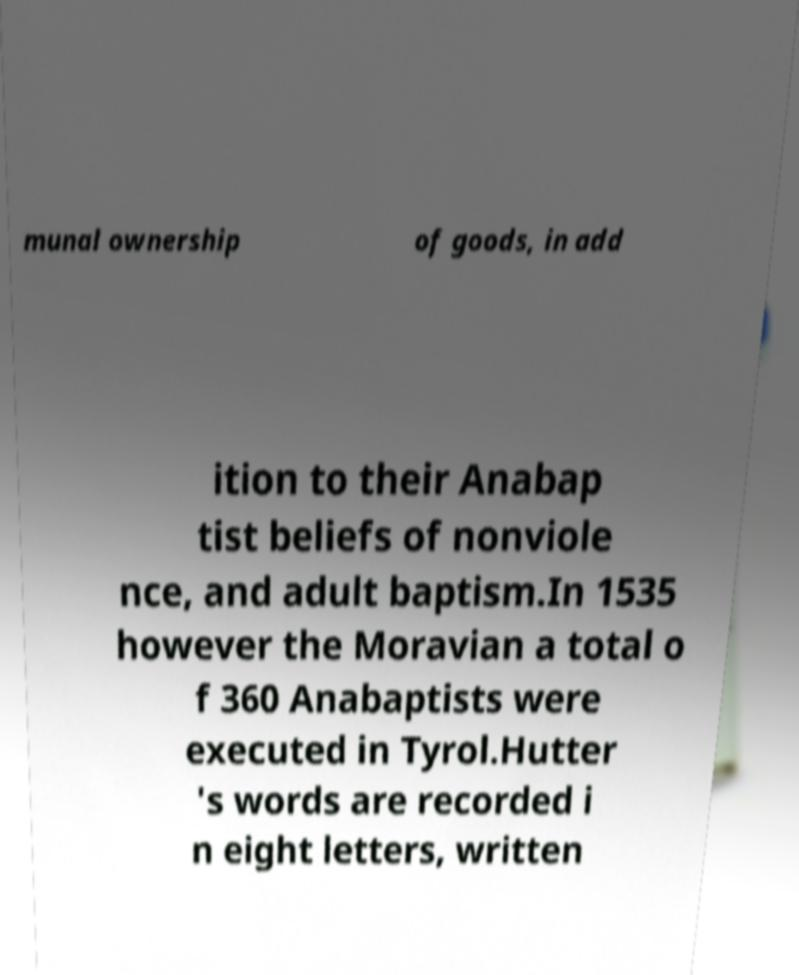Please identify and transcribe the text found in this image. munal ownership of goods, in add ition to their Anabap tist beliefs of nonviole nce, and adult baptism.In 1535 however the Moravian a total o f 360 Anabaptists were executed in Tyrol.Hutter 's words are recorded i n eight letters, written 